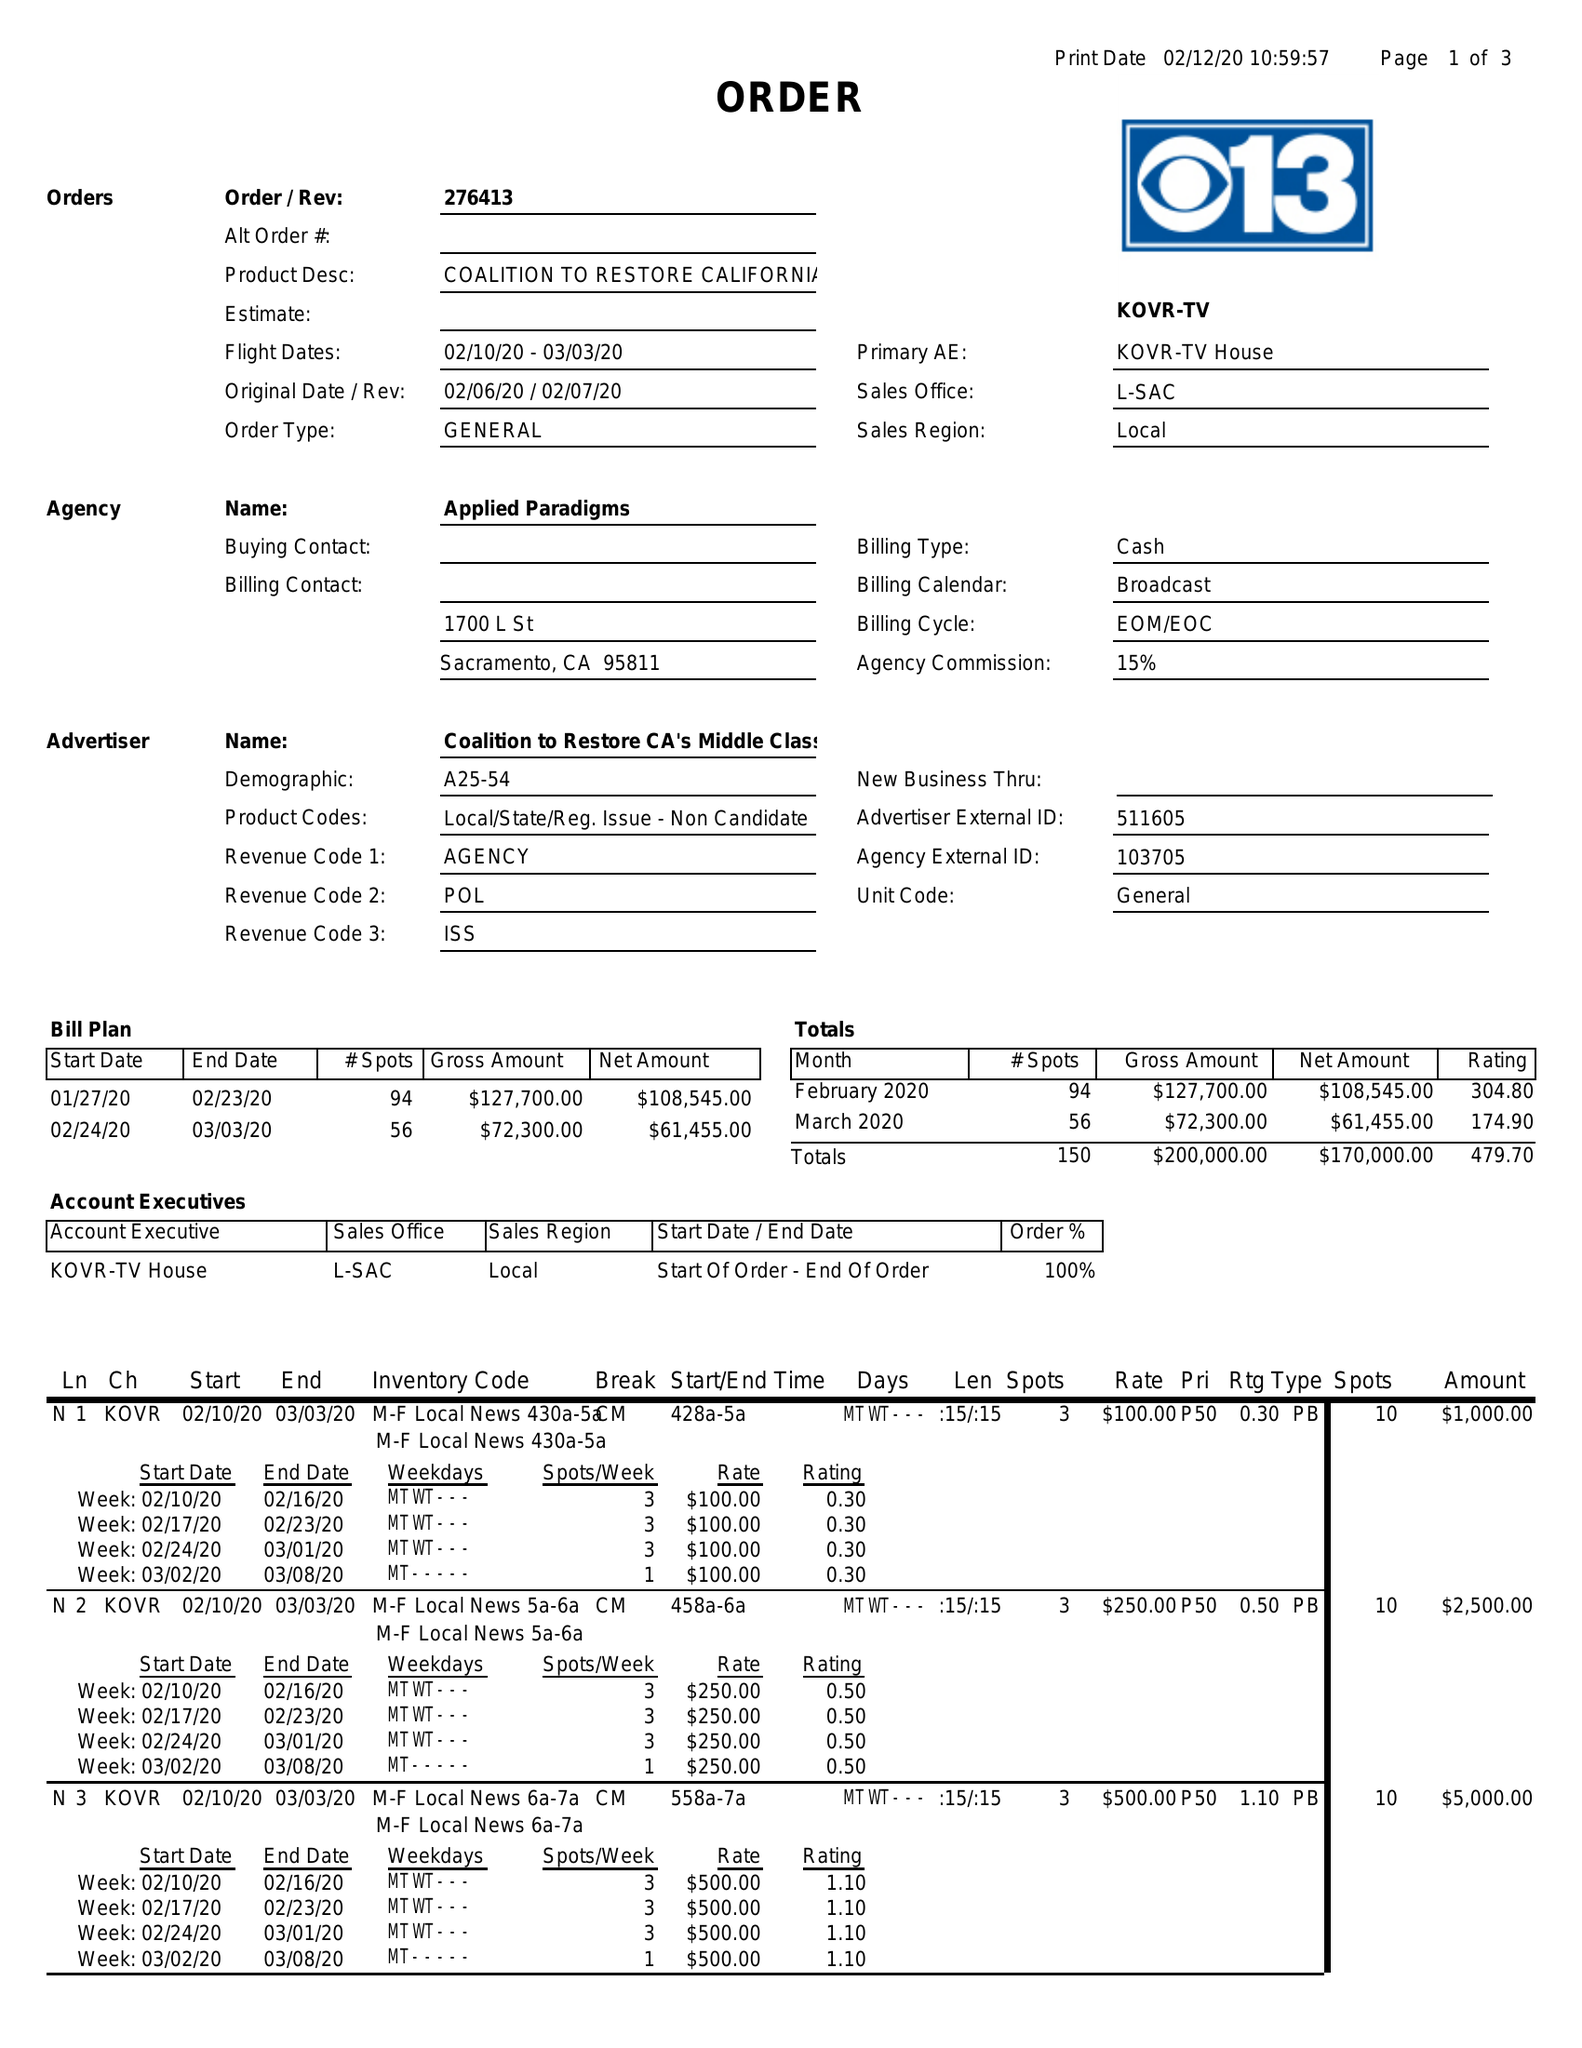What is the value for the contract_num?
Answer the question using a single word or phrase. 276413 